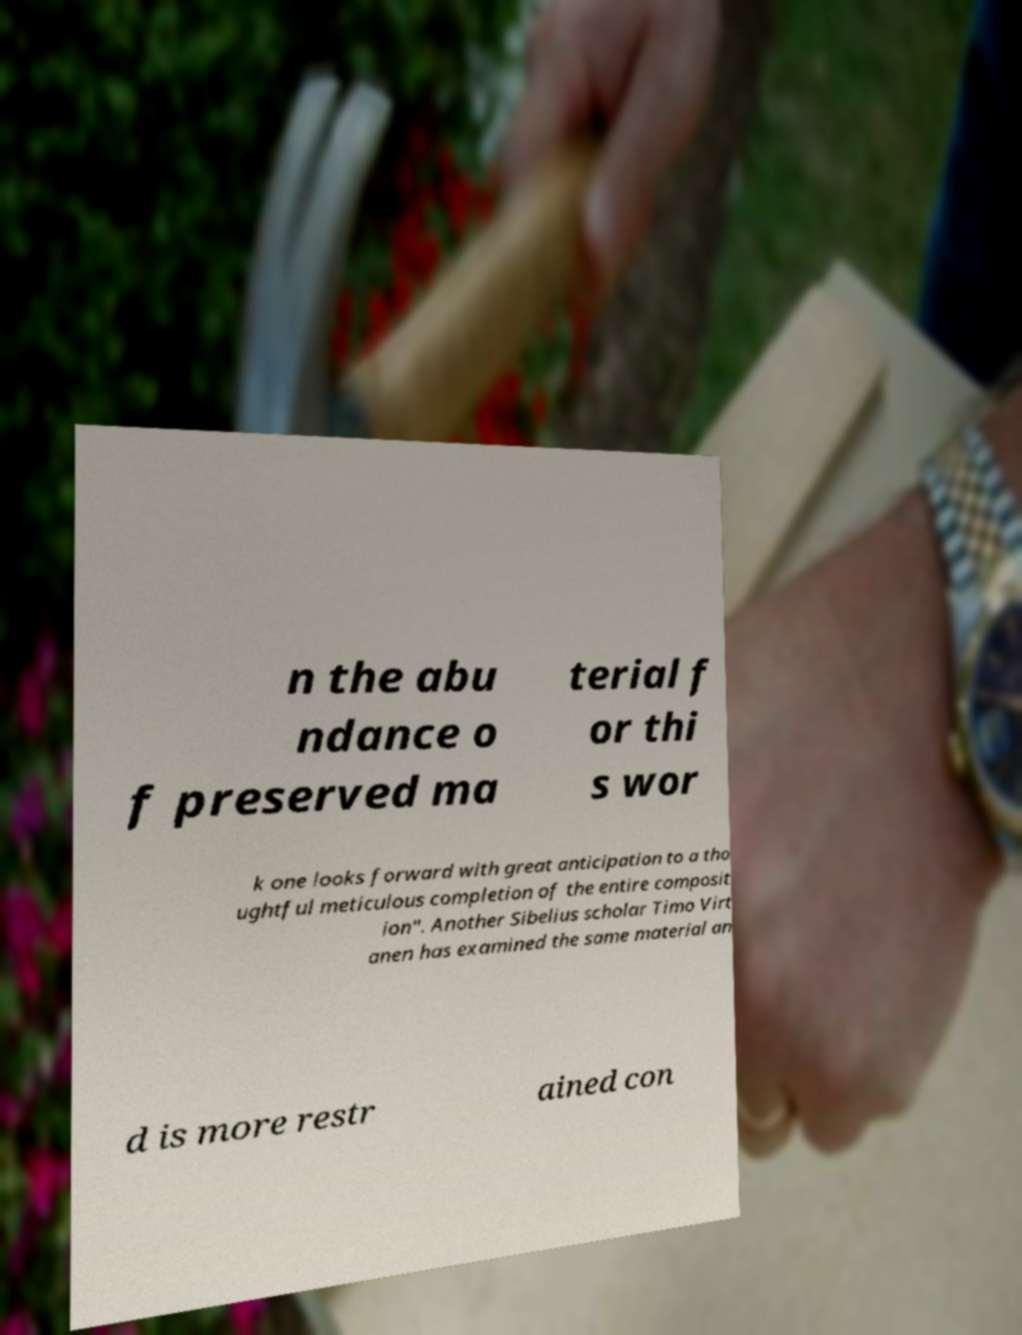What messages or text are displayed in this image? I need them in a readable, typed format. n the abu ndance o f preserved ma terial f or thi s wor k one looks forward with great anticipation to a tho ughtful meticulous completion of the entire composit ion". Another Sibelius scholar Timo Virt anen has examined the same material an d is more restr ained con 